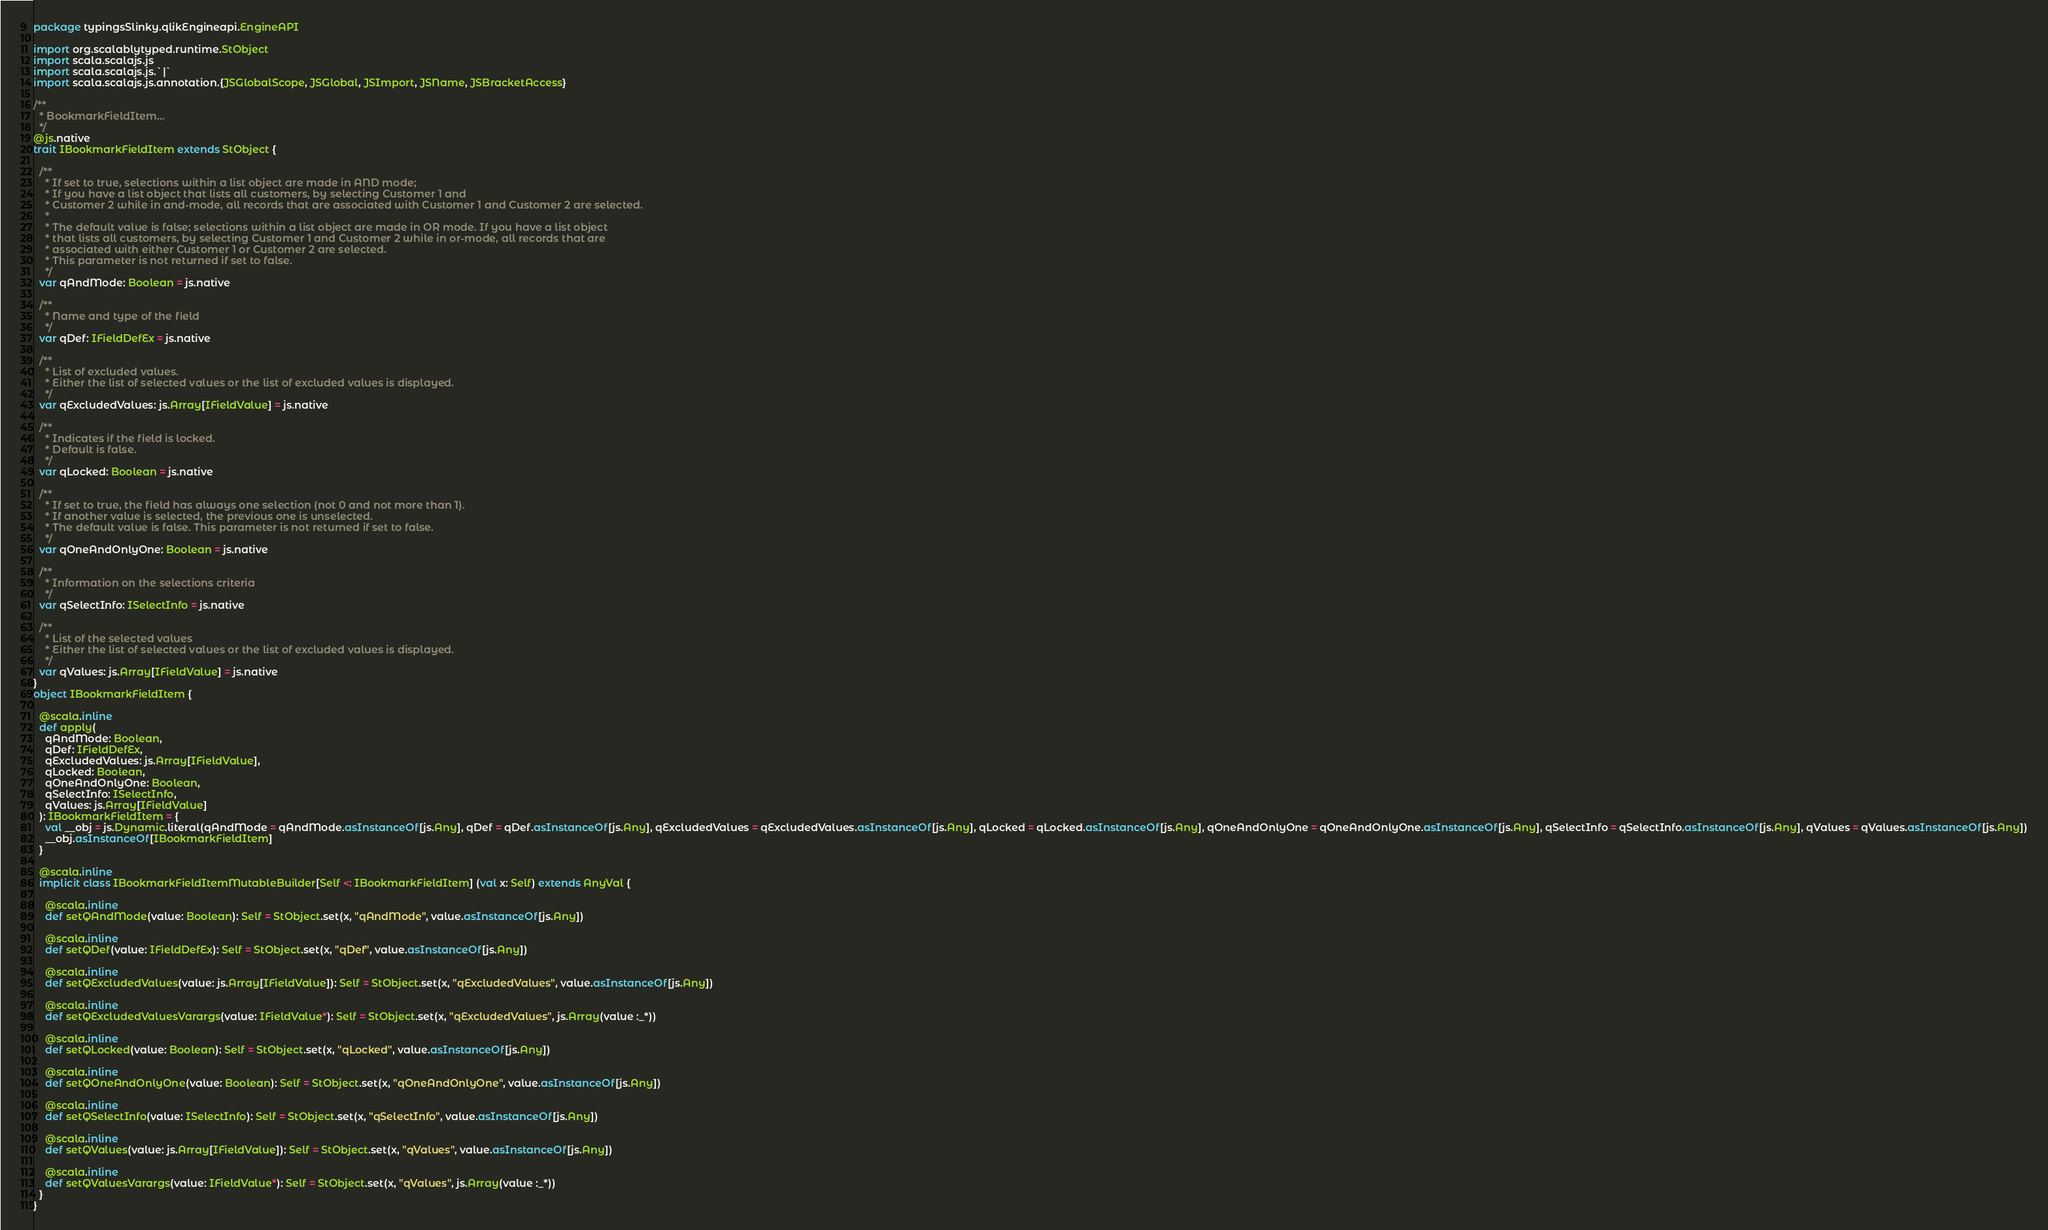Convert code to text. <code><loc_0><loc_0><loc_500><loc_500><_Scala_>package typingsSlinky.qlikEngineapi.EngineAPI

import org.scalablytyped.runtime.StObject
import scala.scalajs.js
import scala.scalajs.js.`|`
import scala.scalajs.js.annotation.{JSGlobalScope, JSGlobal, JSImport, JSName, JSBracketAccess}

/**
  * BookmarkFieldItem...
  */
@js.native
trait IBookmarkFieldItem extends StObject {
  
  /**
    * If set to true, selections within a list object are made in AND mode;
    * If you have a list object that lists all customers, by selecting Customer 1 and
    * Customer 2 while in and-mode, all records that are associated with Customer 1 and Customer 2 are selected.
    *
    * The default value is false; selections within a list object are made in OR mode. If you have a list object
    * that lists all customers, by selecting Customer 1 and Customer 2 while in or-mode, all records that are
    * associated with either Customer 1 or Customer 2 are selected.
    * This parameter is not returned if set to false.
    */
  var qAndMode: Boolean = js.native
  
  /**
    * Name and type of the field
    */
  var qDef: IFieldDefEx = js.native
  
  /**
    * List of excluded values.
    * Either the list of selected values or the list of excluded values is displayed.
    */
  var qExcludedValues: js.Array[IFieldValue] = js.native
  
  /**
    * Indicates if the field is locked.
    * Default is false.
    */
  var qLocked: Boolean = js.native
  
  /**
    * If set to true, the field has always one selection (not 0 and not more than 1).
    * If another value is selected, the previous one is unselected.
    * The default value is false. This parameter is not returned if set to false.
    */
  var qOneAndOnlyOne: Boolean = js.native
  
  /**
    * Information on the selections criteria
    */
  var qSelectInfo: ISelectInfo = js.native
  
  /**
    * List of the selected values
    * Either the list of selected values or the list of excluded values is displayed.
    */
  var qValues: js.Array[IFieldValue] = js.native
}
object IBookmarkFieldItem {
  
  @scala.inline
  def apply(
    qAndMode: Boolean,
    qDef: IFieldDefEx,
    qExcludedValues: js.Array[IFieldValue],
    qLocked: Boolean,
    qOneAndOnlyOne: Boolean,
    qSelectInfo: ISelectInfo,
    qValues: js.Array[IFieldValue]
  ): IBookmarkFieldItem = {
    val __obj = js.Dynamic.literal(qAndMode = qAndMode.asInstanceOf[js.Any], qDef = qDef.asInstanceOf[js.Any], qExcludedValues = qExcludedValues.asInstanceOf[js.Any], qLocked = qLocked.asInstanceOf[js.Any], qOneAndOnlyOne = qOneAndOnlyOne.asInstanceOf[js.Any], qSelectInfo = qSelectInfo.asInstanceOf[js.Any], qValues = qValues.asInstanceOf[js.Any])
    __obj.asInstanceOf[IBookmarkFieldItem]
  }
  
  @scala.inline
  implicit class IBookmarkFieldItemMutableBuilder[Self <: IBookmarkFieldItem] (val x: Self) extends AnyVal {
    
    @scala.inline
    def setQAndMode(value: Boolean): Self = StObject.set(x, "qAndMode", value.asInstanceOf[js.Any])
    
    @scala.inline
    def setQDef(value: IFieldDefEx): Self = StObject.set(x, "qDef", value.asInstanceOf[js.Any])
    
    @scala.inline
    def setQExcludedValues(value: js.Array[IFieldValue]): Self = StObject.set(x, "qExcludedValues", value.asInstanceOf[js.Any])
    
    @scala.inline
    def setQExcludedValuesVarargs(value: IFieldValue*): Self = StObject.set(x, "qExcludedValues", js.Array(value :_*))
    
    @scala.inline
    def setQLocked(value: Boolean): Self = StObject.set(x, "qLocked", value.asInstanceOf[js.Any])
    
    @scala.inline
    def setQOneAndOnlyOne(value: Boolean): Self = StObject.set(x, "qOneAndOnlyOne", value.asInstanceOf[js.Any])
    
    @scala.inline
    def setQSelectInfo(value: ISelectInfo): Self = StObject.set(x, "qSelectInfo", value.asInstanceOf[js.Any])
    
    @scala.inline
    def setQValues(value: js.Array[IFieldValue]): Self = StObject.set(x, "qValues", value.asInstanceOf[js.Any])
    
    @scala.inline
    def setQValuesVarargs(value: IFieldValue*): Self = StObject.set(x, "qValues", js.Array(value :_*))
  }
}
</code> 